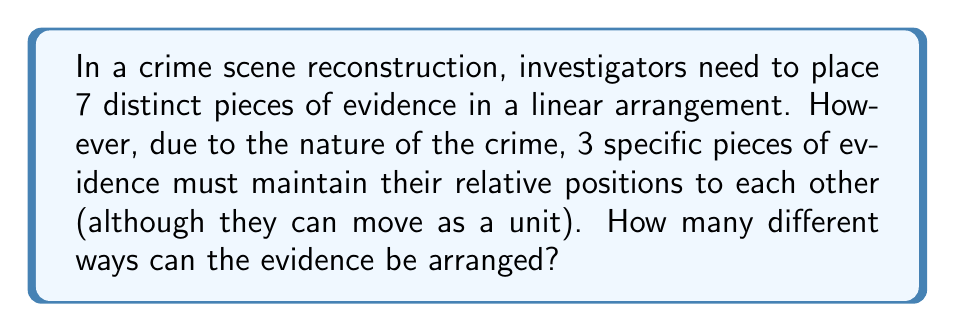Could you help me with this problem? Let's approach this step-by-step:

1) First, we need to consider the 3 pieces of evidence that must maintain their relative positions. We can treat these 3 pieces as one unit.

2) So now, instead of arranging 7 individual pieces, we are essentially arranging 5 elements: the unit of 3 pieces and the other 4 individual pieces.

3) The number of ways to arrange 5 distinct elements is a straightforward permutation:

   $$P(5,5) = 5! = 5 \times 4 \times 3 \times 2 \times 1 = 120$$

4) However, we're not done yet. For each of these 120 arrangements, the 3 pieces within our "unit" can also be arranged in different ways.

5) The number of ways to arrange these 3 pieces is another permutation:

   $$P(3,3) = 3! = 3 \times 2 \times 1 = 6$$

6) By the multiplication principle, the total number of possible arrangements is the product of the number of ways to arrange the 5 elements and the number of ways to arrange the 3 pieces within the unit:

   $$120 \times 6 = 720$$

Therefore, there are 720 different ways to arrange the evidence.
Answer: 720 